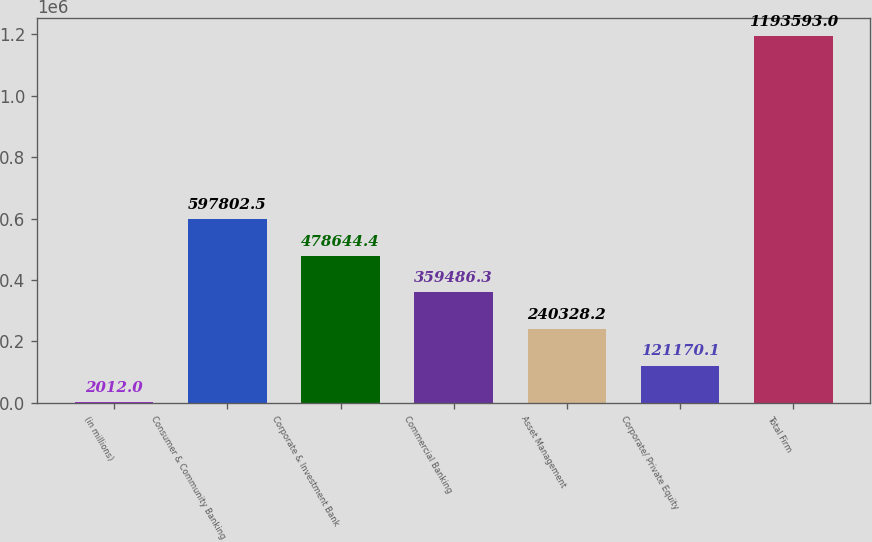Convert chart to OTSL. <chart><loc_0><loc_0><loc_500><loc_500><bar_chart><fcel>(in millions)<fcel>Consumer & Community Banking<fcel>Corporate & Investment Bank<fcel>Commercial Banking<fcel>Asset Management<fcel>Corporate/ Private Equity<fcel>Total Firm<nl><fcel>2012<fcel>597802<fcel>478644<fcel>359486<fcel>240328<fcel>121170<fcel>1.19359e+06<nl></chart> 